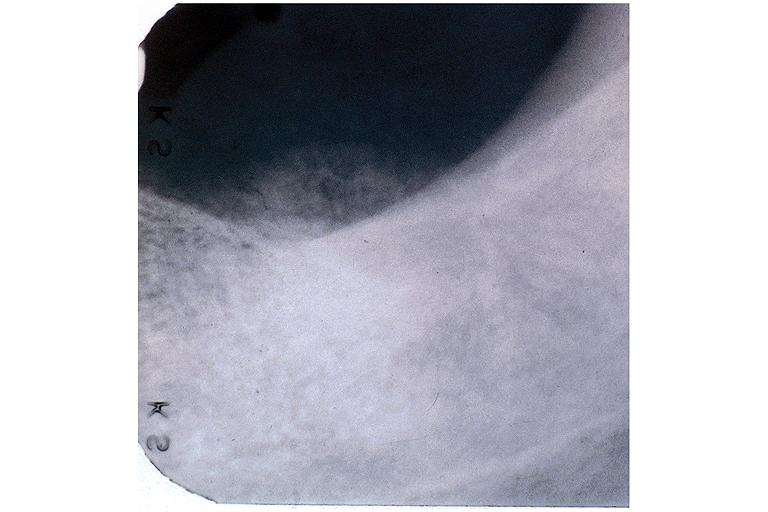what does this image show?
Answer the question using a single word or phrase. Osteosarcoma 